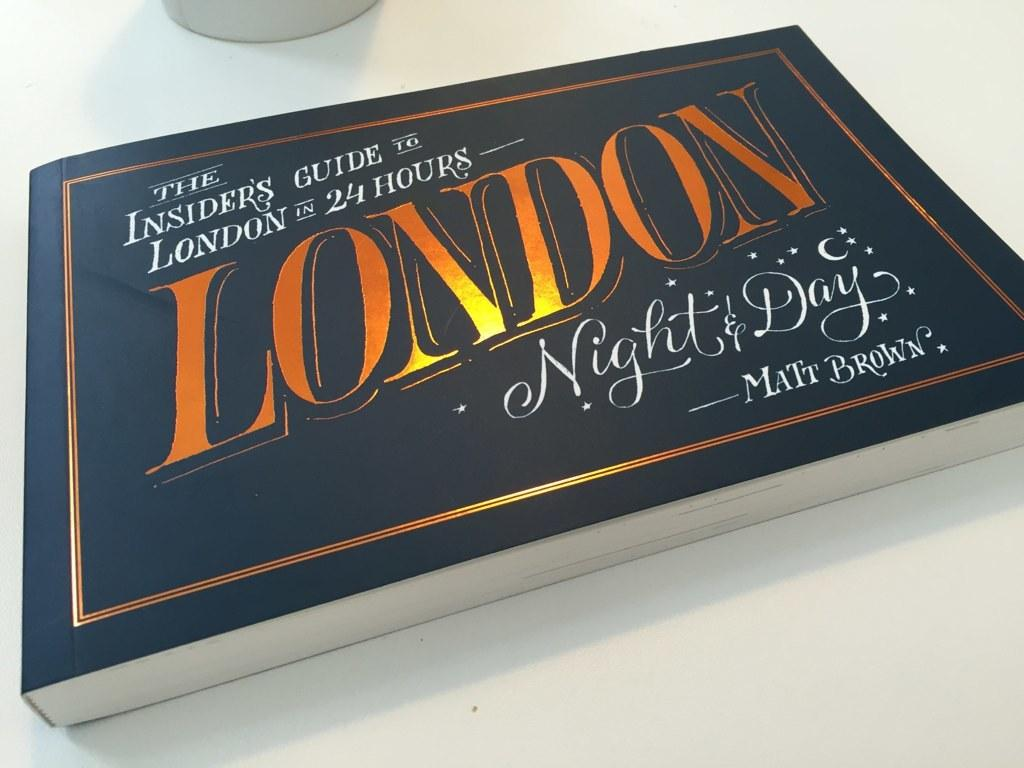<image>
Create a compact narrative representing the image presented. The book is called 24 Hours London Night & Day. 